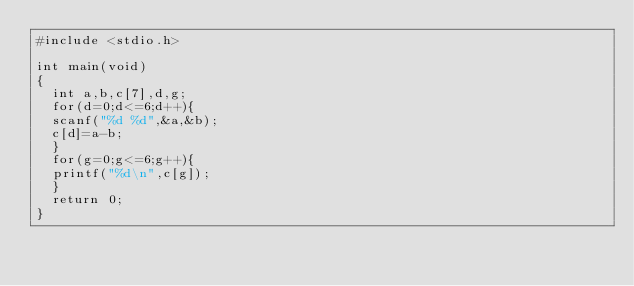Convert code to text. <code><loc_0><loc_0><loc_500><loc_500><_C_>#include <stdio.h>

int main(void)
{
	int a,b,c[7],d,g;
	for(d=0;d<=6;d++){
	scanf("%d %d",&a,&b);
	c[d]=a-b;
	}
	for(g=0;g<=6;g++){
	printf("%d\n",c[g]);
	}
	return 0;
}
</code> 